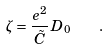<formula> <loc_0><loc_0><loc_500><loc_500>\zeta = \frac { e ^ { 2 } } { \tilde { C } } \, D _ { 0 } \quad .</formula> 